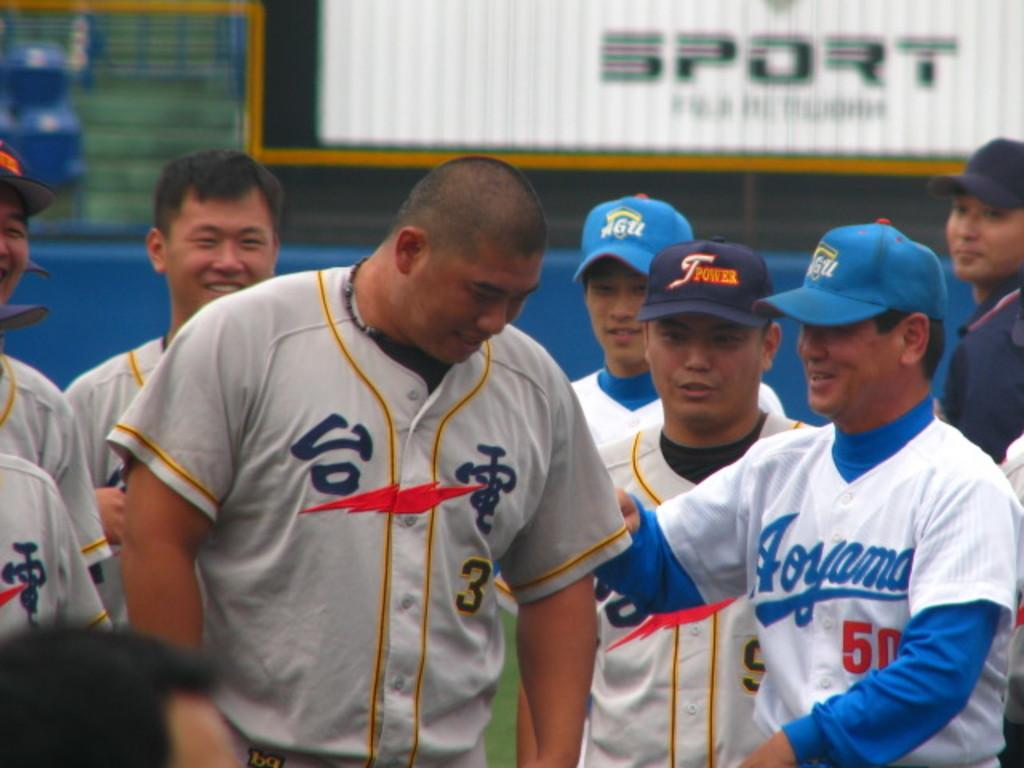<image>
Describe the image concisely. a few players with Japanese language on their jerseys with one man wearing 50 